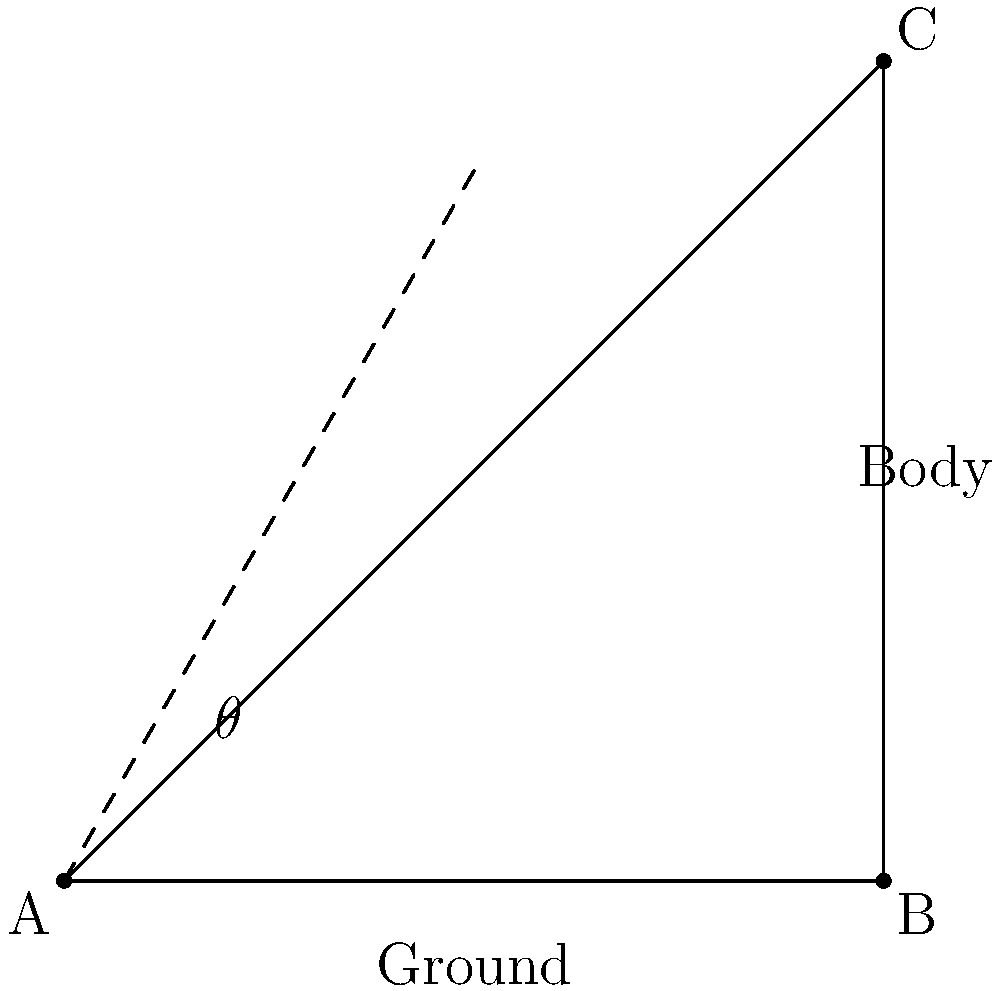During a mindful walking exercise, you want to maintain proper posture by keeping your body at an optimal angle. If the angle between your body and the ground is represented by $\theta$ in the diagram, what should be the value of $\theta$ to achieve a 30-60-90 triangle formation for optimal posture? To solve this problem, let's follow these steps:

1. Recall the properties of a 30-60-90 triangle:
   - The angles are 30°, 60°, and 90°
   - The side ratios are 1 : $\sqrt{3}$ : 2

2. In our diagram, we want the angle between the body and the ground ($\theta$) to form a 30-60-90 triangle.

3. The right angle (90°) is formed where the body meets the ground.

4. For the body to be at the optimal angle, it should form the hypotenuse of the 30-60-90 triangle.

5. The angle we're looking for ($\theta$) is the angle between the hypotenuse (body) and the shorter leg (ground) of the 30-60-90 triangle.

6. In a 30-60-90 triangle, the largest angle (90°) is opposite the hypotenuse, the second largest angle (60°) is opposite the medium-length side, and the smallest angle (30°) is opposite the shortest side.

7. Therefore, the angle between the hypotenuse (body) and the shorter leg (ground) must be 60°.

So, the optimal angle $\theta$ for proper posture during this mindful walking exercise is 60°.
Answer: 60° 